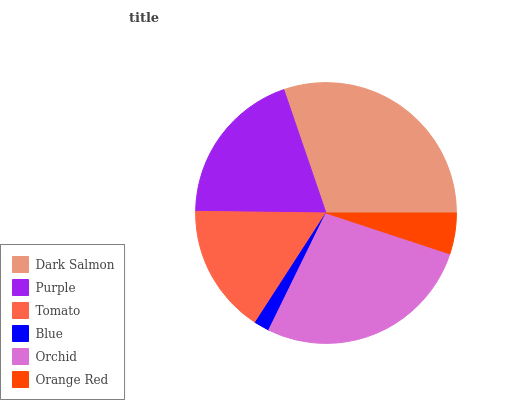Is Blue the minimum?
Answer yes or no. Yes. Is Dark Salmon the maximum?
Answer yes or no. Yes. Is Purple the minimum?
Answer yes or no. No. Is Purple the maximum?
Answer yes or no. No. Is Dark Salmon greater than Purple?
Answer yes or no. Yes. Is Purple less than Dark Salmon?
Answer yes or no. Yes. Is Purple greater than Dark Salmon?
Answer yes or no. No. Is Dark Salmon less than Purple?
Answer yes or no. No. Is Purple the high median?
Answer yes or no. Yes. Is Tomato the low median?
Answer yes or no. Yes. Is Dark Salmon the high median?
Answer yes or no. No. Is Orange Red the low median?
Answer yes or no. No. 